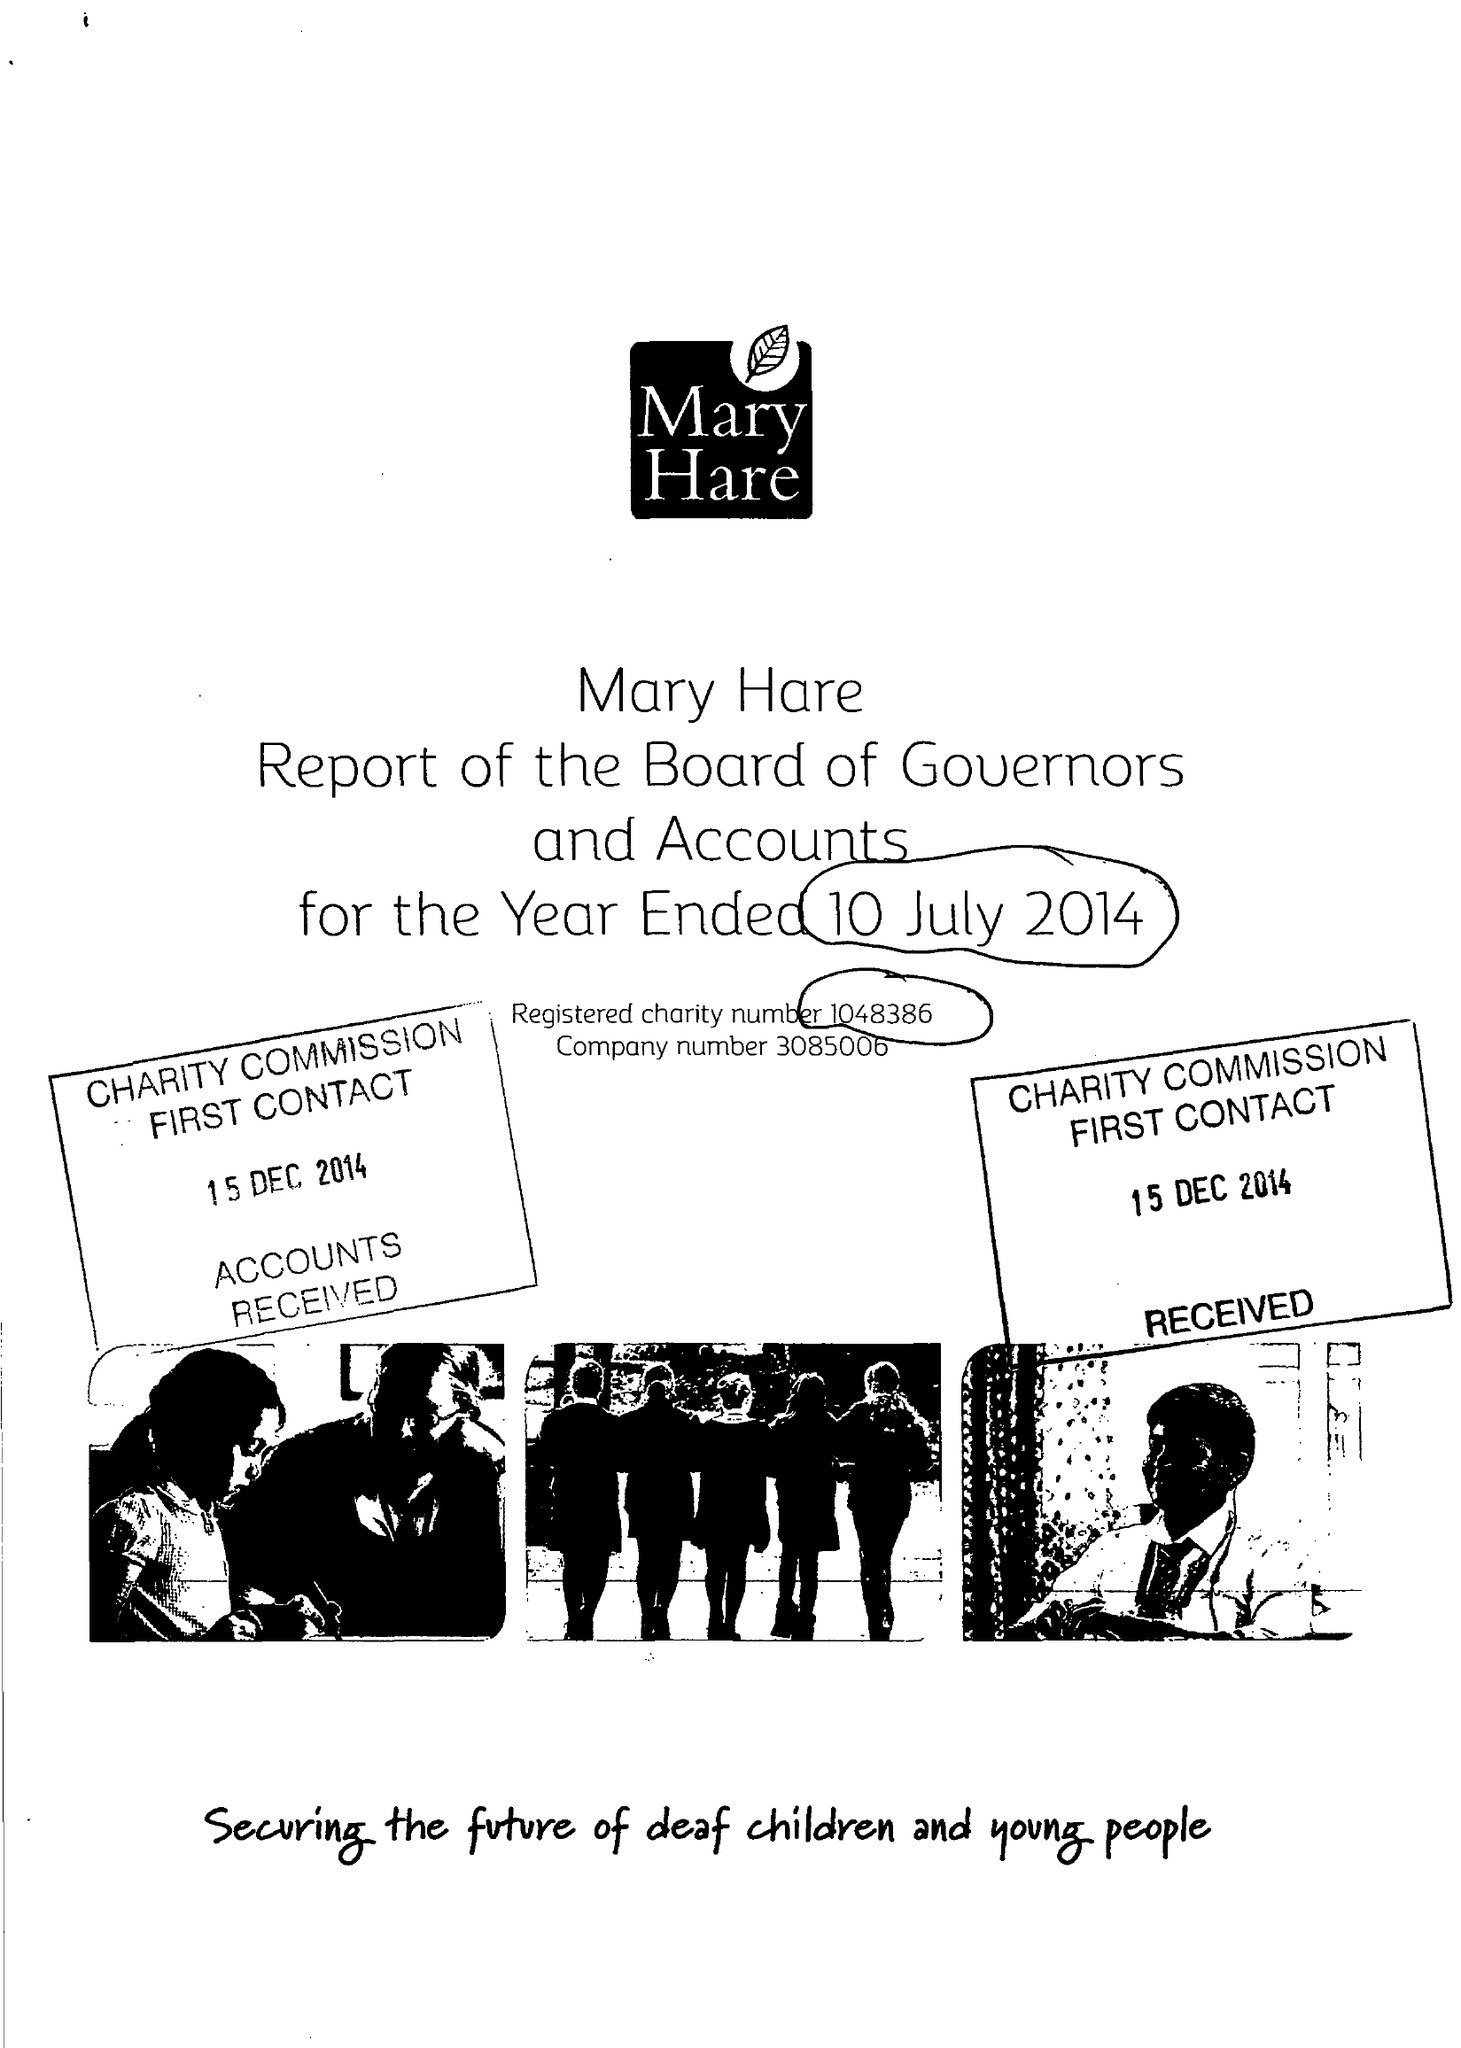What is the value for the spending_annually_in_british_pounds?
Answer the question using a single word or phrase. 10254000.00 